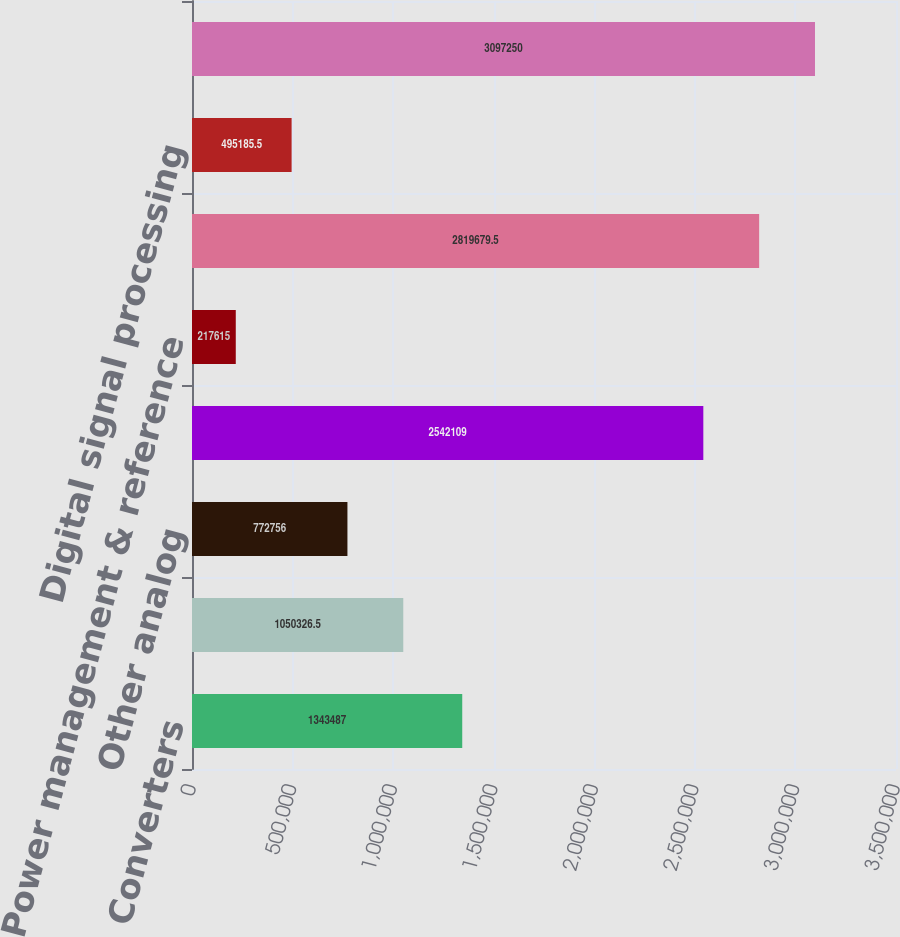Convert chart. <chart><loc_0><loc_0><loc_500><loc_500><bar_chart><fcel>Converters<fcel>Amplifiers/Radio frequency<fcel>Other analog<fcel>Subtotal analog signal<fcel>Power management & reference<fcel>Total analog products<fcel>Digital signal processing<fcel>Total Revenue<nl><fcel>1.34349e+06<fcel>1.05033e+06<fcel>772756<fcel>2.54211e+06<fcel>217615<fcel>2.81968e+06<fcel>495186<fcel>3.09725e+06<nl></chart> 